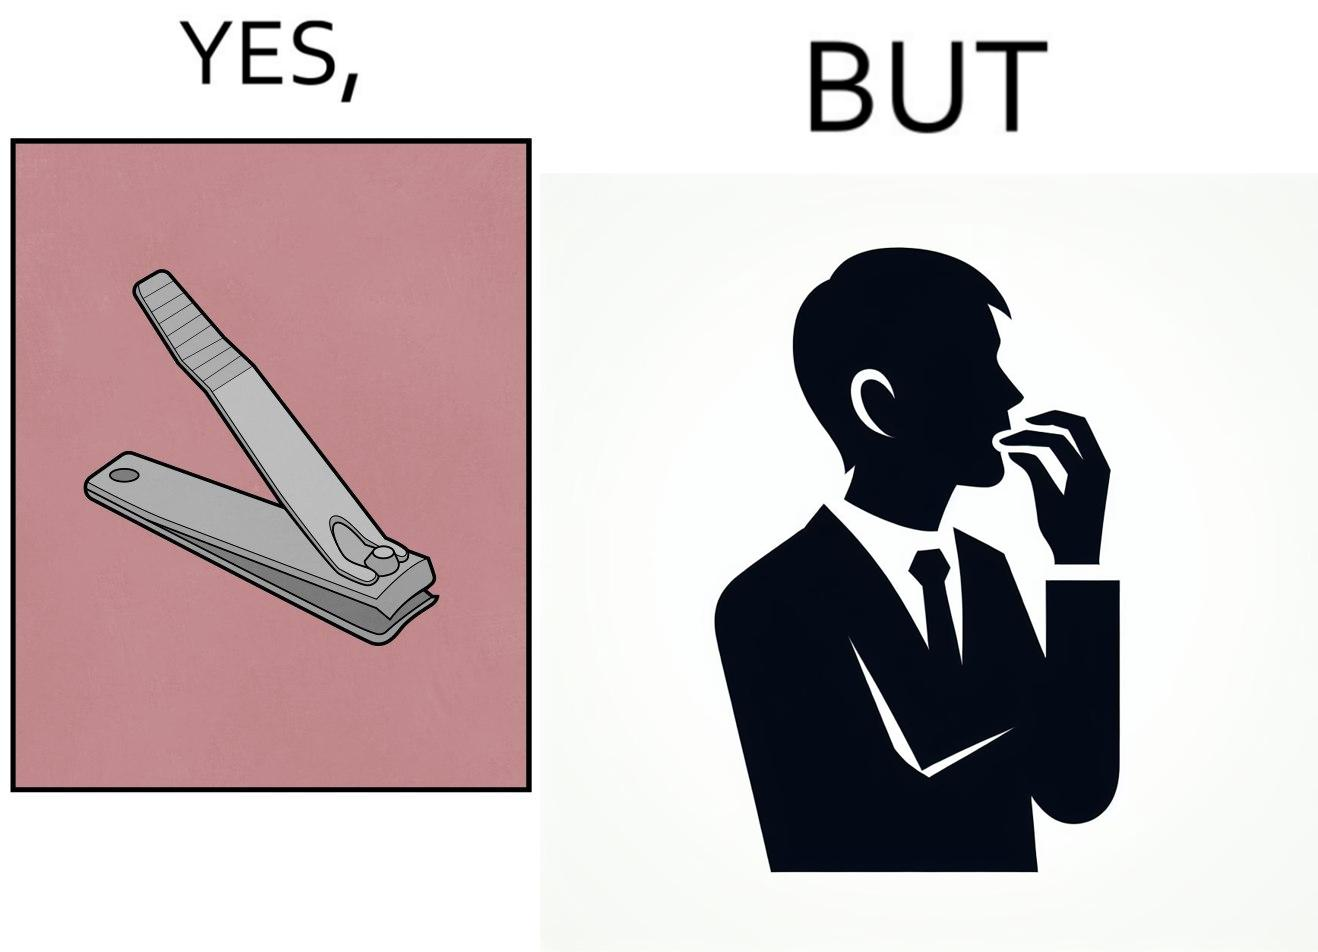What do you see in each half of this image? In the left part of the image: a nail clipper In the right part of the image: a person biting their nails to cut them 